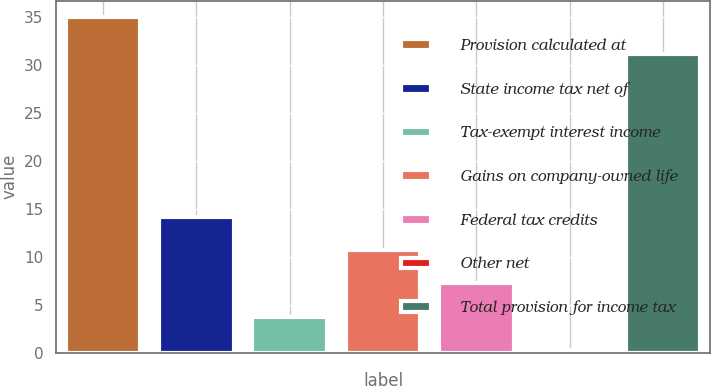Convert chart to OTSL. <chart><loc_0><loc_0><loc_500><loc_500><bar_chart><fcel>Provision calculated at<fcel>State income tax net of<fcel>Tax-exempt interest income<fcel>Gains on company-owned life<fcel>Federal tax credits<fcel>Other net<fcel>Total provision for income tax<nl><fcel>35<fcel>14.18<fcel>3.77<fcel>10.71<fcel>7.24<fcel>0.3<fcel>31.2<nl></chart> 